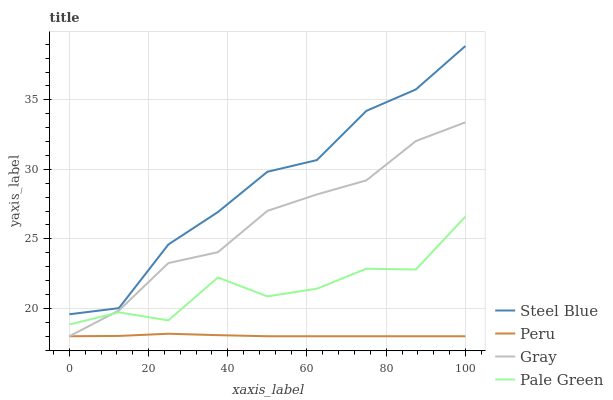Does Pale Green have the minimum area under the curve?
Answer yes or no. No. Does Pale Green have the maximum area under the curve?
Answer yes or no. No. Is Steel Blue the smoothest?
Answer yes or no. No. Is Steel Blue the roughest?
Answer yes or no. No. Does Pale Green have the lowest value?
Answer yes or no. No. Does Pale Green have the highest value?
Answer yes or no. No. Is Gray less than Steel Blue?
Answer yes or no. Yes. Is Steel Blue greater than Peru?
Answer yes or no. Yes. Does Gray intersect Steel Blue?
Answer yes or no. No. 